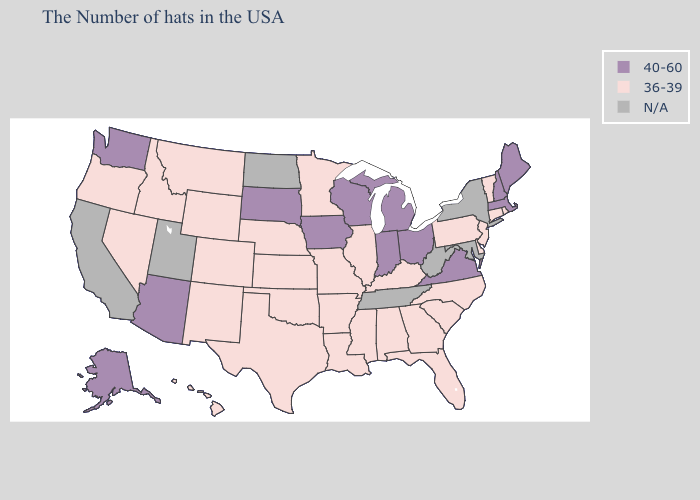What is the highest value in the South ?
Short answer required. 40-60. Name the states that have a value in the range 40-60?
Be succinct. Maine, Massachusetts, New Hampshire, Virginia, Ohio, Michigan, Indiana, Wisconsin, Iowa, South Dakota, Arizona, Washington, Alaska. Does the map have missing data?
Keep it brief. Yes. Among the states that border Nevada , which have the lowest value?
Give a very brief answer. Idaho, Oregon. How many symbols are there in the legend?
Concise answer only. 3. Does the map have missing data?
Short answer required. Yes. Which states have the lowest value in the West?
Give a very brief answer. Wyoming, Colorado, New Mexico, Montana, Idaho, Nevada, Oregon, Hawaii. What is the lowest value in states that border Kentucky?
Quick response, please. 36-39. Does Wisconsin have the highest value in the USA?
Write a very short answer. Yes. What is the highest value in states that border Texas?
Answer briefly. 36-39. Among the states that border Montana , does South Dakota have the lowest value?
Give a very brief answer. No. What is the highest value in states that border South Carolina?
Keep it brief. 36-39. Which states have the highest value in the USA?
Concise answer only. Maine, Massachusetts, New Hampshire, Virginia, Ohio, Michigan, Indiana, Wisconsin, Iowa, South Dakota, Arizona, Washington, Alaska. Name the states that have a value in the range N/A?
Concise answer only. New York, Maryland, West Virginia, Tennessee, North Dakota, Utah, California. Name the states that have a value in the range N/A?
Answer briefly. New York, Maryland, West Virginia, Tennessee, North Dakota, Utah, California. 